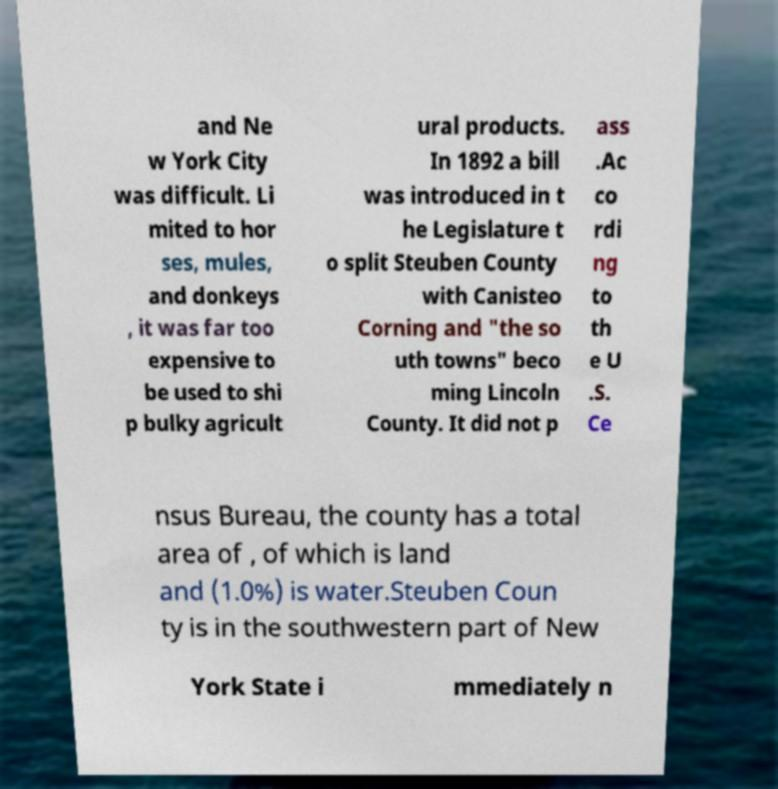Please identify and transcribe the text found in this image. and Ne w York City was difficult. Li mited to hor ses, mules, and donkeys , it was far too expensive to be used to shi p bulky agricult ural products. In 1892 a bill was introduced in t he Legislature t o split Steuben County with Canisteo Corning and "the so uth towns" beco ming Lincoln County. It did not p ass .Ac co rdi ng to th e U .S. Ce nsus Bureau, the county has a total area of , of which is land and (1.0%) is water.Steuben Coun ty is in the southwestern part of New York State i mmediately n 